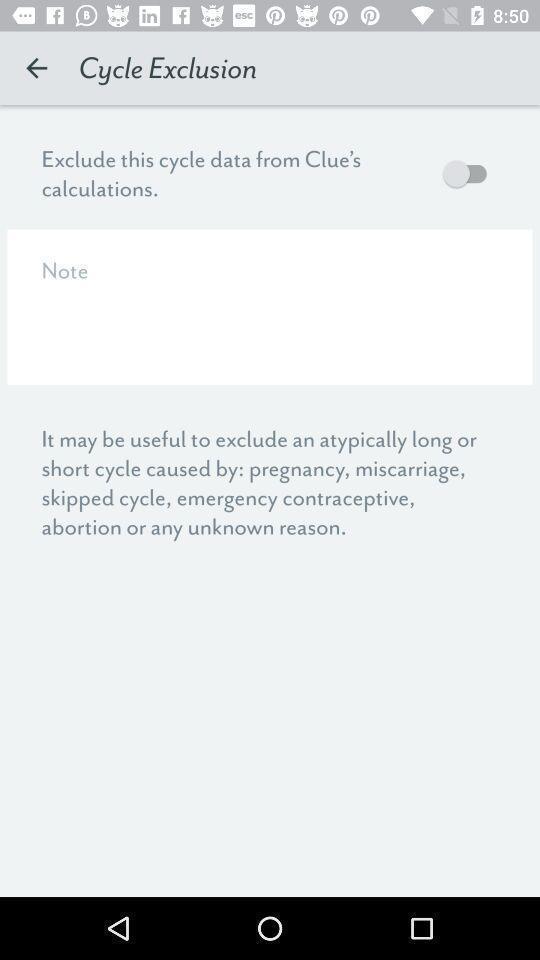What can you discern from this picture? Settings page of a period tracking app. 